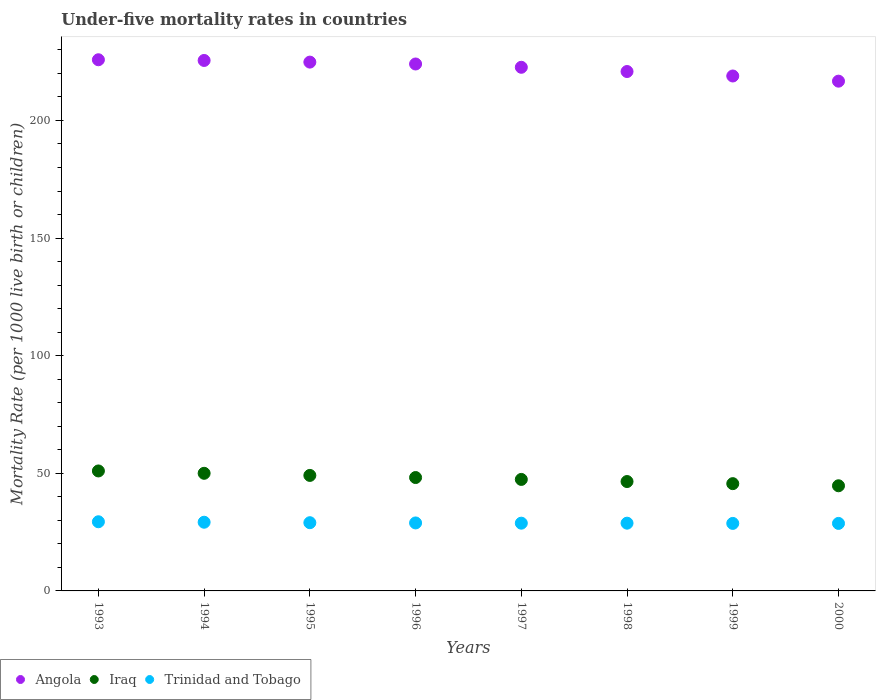Is the number of dotlines equal to the number of legend labels?
Offer a terse response. Yes. What is the under-five mortality rate in Angola in 1997?
Offer a terse response. 222.6. Across all years, what is the maximum under-five mortality rate in Trinidad and Tobago?
Your response must be concise. 29.4. Across all years, what is the minimum under-five mortality rate in Trinidad and Tobago?
Your answer should be very brief. 28.7. In which year was the under-five mortality rate in Iraq minimum?
Give a very brief answer. 2000. What is the total under-five mortality rate in Trinidad and Tobago in the graph?
Offer a very short reply. 231.5. What is the difference between the under-five mortality rate in Iraq in 1993 and that in 2000?
Provide a short and direct response. 6.3. What is the difference between the under-five mortality rate in Trinidad and Tobago in 1999 and the under-five mortality rate in Iraq in 1996?
Offer a terse response. -19.5. What is the average under-five mortality rate in Iraq per year?
Offer a very short reply. 47.81. In the year 2000, what is the difference between the under-five mortality rate in Iraq and under-five mortality rate in Angola?
Your response must be concise. -172. What is the ratio of the under-five mortality rate in Iraq in 1994 to that in 1995?
Your response must be concise. 1.02. Is the under-five mortality rate in Angola in 1993 less than that in 1999?
Ensure brevity in your answer.  No. Is the difference between the under-five mortality rate in Iraq in 1994 and 1997 greater than the difference between the under-five mortality rate in Angola in 1994 and 1997?
Make the answer very short. No. What is the difference between the highest and the lowest under-five mortality rate in Iraq?
Provide a short and direct response. 6.3. In how many years, is the under-five mortality rate in Iraq greater than the average under-five mortality rate in Iraq taken over all years?
Ensure brevity in your answer.  4. Is the sum of the under-five mortality rate in Angola in 1993 and 1994 greater than the maximum under-five mortality rate in Trinidad and Tobago across all years?
Ensure brevity in your answer.  Yes. Is it the case that in every year, the sum of the under-five mortality rate in Angola and under-five mortality rate in Trinidad and Tobago  is greater than the under-five mortality rate in Iraq?
Provide a succinct answer. Yes. Is the under-five mortality rate in Trinidad and Tobago strictly less than the under-five mortality rate in Iraq over the years?
Give a very brief answer. Yes. How many dotlines are there?
Give a very brief answer. 3. Does the graph contain any zero values?
Offer a very short reply. No. How are the legend labels stacked?
Provide a short and direct response. Horizontal. What is the title of the graph?
Offer a very short reply. Under-five mortality rates in countries. Does "Denmark" appear as one of the legend labels in the graph?
Keep it short and to the point. No. What is the label or title of the Y-axis?
Provide a succinct answer. Mortality Rate (per 1000 live birth or children). What is the Mortality Rate (per 1000 live birth or children) in Angola in 1993?
Provide a short and direct response. 225.8. What is the Mortality Rate (per 1000 live birth or children) of Iraq in 1993?
Provide a succinct answer. 51. What is the Mortality Rate (per 1000 live birth or children) in Trinidad and Tobago in 1993?
Provide a short and direct response. 29.4. What is the Mortality Rate (per 1000 live birth or children) of Angola in 1994?
Your answer should be very brief. 225.5. What is the Mortality Rate (per 1000 live birth or children) of Trinidad and Tobago in 1994?
Provide a short and direct response. 29.2. What is the Mortality Rate (per 1000 live birth or children) in Angola in 1995?
Offer a very short reply. 224.8. What is the Mortality Rate (per 1000 live birth or children) in Iraq in 1995?
Your response must be concise. 49.1. What is the Mortality Rate (per 1000 live birth or children) in Angola in 1996?
Make the answer very short. 224. What is the Mortality Rate (per 1000 live birth or children) in Iraq in 1996?
Offer a terse response. 48.2. What is the Mortality Rate (per 1000 live birth or children) in Trinidad and Tobago in 1996?
Your response must be concise. 28.9. What is the Mortality Rate (per 1000 live birth or children) of Angola in 1997?
Offer a very short reply. 222.6. What is the Mortality Rate (per 1000 live birth or children) in Iraq in 1997?
Give a very brief answer. 47.4. What is the Mortality Rate (per 1000 live birth or children) in Trinidad and Tobago in 1997?
Make the answer very short. 28.8. What is the Mortality Rate (per 1000 live birth or children) of Angola in 1998?
Keep it short and to the point. 220.8. What is the Mortality Rate (per 1000 live birth or children) of Iraq in 1998?
Give a very brief answer. 46.5. What is the Mortality Rate (per 1000 live birth or children) of Trinidad and Tobago in 1998?
Keep it short and to the point. 28.8. What is the Mortality Rate (per 1000 live birth or children) in Angola in 1999?
Keep it short and to the point. 218.9. What is the Mortality Rate (per 1000 live birth or children) of Iraq in 1999?
Provide a short and direct response. 45.6. What is the Mortality Rate (per 1000 live birth or children) of Trinidad and Tobago in 1999?
Give a very brief answer. 28.7. What is the Mortality Rate (per 1000 live birth or children) of Angola in 2000?
Give a very brief answer. 216.7. What is the Mortality Rate (per 1000 live birth or children) of Iraq in 2000?
Your answer should be very brief. 44.7. What is the Mortality Rate (per 1000 live birth or children) of Trinidad and Tobago in 2000?
Make the answer very short. 28.7. Across all years, what is the maximum Mortality Rate (per 1000 live birth or children) in Angola?
Give a very brief answer. 225.8. Across all years, what is the maximum Mortality Rate (per 1000 live birth or children) in Trinidad and Tobago?
Offer a terse response. 29.4. Across all years, what is the minimum Mortality Rate (per 1000 live birth or children) of Angola?
Ensure brevity in your answer.  216.7. Across all years, what is the minimum Mortality Rate (per 1000 live birth or children) in Iraq?
Make the answer very short. 44.7. Across all years, what is the minimum Mortality Rate (per 1000 live birth or children) of Trinidad and Tobago?
Your response must be concise. 28.7. What is the total Mortality Rate (per 1000 live birth or children) of Angola in the graph?
Ensure brevity in your answer.  1779.1. What is the total Mortality Rate (per 1000 live birth or children) in Iraq in the graph?
Offer a very short reply. 382.5. What is the total Mortality Rate (per 1000 live birth or children) of Trinidad and Tobago in the graph?
Your answer should be compact. 231.5. What is the difference between the Mortality Rate (per 1000 live birth or children) of Iraq in 1993 and that in 1994?
Give a very brief answer. 1. What is the difference between the Mortality Rate (per 1000 live birth or children) of Trinidad and Tobago in 1993 and that in 1994?
Your answer should be very brief. 0.2. What is the difference between the Mortality Rate (per 1000 live birth or children) of Iraq in 1993 and that in 1995?
Provide a short and direct response. 1.9. What is the difference between the Mortality Rate (per 1000 live birth or children) in Trinidad and Tobago in 1993 and that in 1995?
Provide a short and direct response. 0.4. What is the difference between the Mortality Rate (per 1000 live birth or children) of Angola in 1993 and that in 1996?
Your response must be concise. 1.8. What is the difference between the Mortality Rate (per 1000 live birth or children) in Trinidad and Tobago in 1993 and that in 1996?
Your response must be concise. 0.5. What is the difference between the Mortality Rate (per 1000 live birth or children) in Angola in 1993 and that in 1997?
Make the answer very short. 3.2. What is the difference between the Mortality Rate (per 1000 live birth or children) in Trinidad and Tobago in 1993 and that in 1997?
Offer a very short reply. 0.6. What is the difference between the Mortality Rate (per 1000 live birth or children) of Trinidad and Tobago in 1993 and that in 1998?
Offer a terse response. 0.6. What is the difference between the Mortality Rate (per 1000 live birth or children) in Angola in 1993 and that in 1999?
Your response must be concise. 6.9. What is the difference between the Mortality Rate (per 1000 live birth or children) in Iraq in 1993 and that in 1999?
Offer a very short reply. 5.4. What is the difference between the Mortality Rate (per 1000 live birth or children) in Trinidad and Tobago in 1993 and that in 1999?
Provide a succinct answer. 0.7. What is the difference between the Mortality Rate (per 1000 live birth or children) in Angola in 1993 and that in 2000?
Provide a short and direct response. 9.1. What is the difference between the Mortality Rate (per 1000 live birth or children) in Iraq in 1993 and that in 2000?
Your answer should be very brief. 6.3. What is the difference between the Mortality Rate (per 1000 live birth or children) in Trinidad and Tobago in 1993 and that in 2000?
Make the answer very short. 0.7. What is the difference between the Mortality Rate (per 1000 live birth or children) of Angola in 1994 and that in 1995?
Offer a very short reply. 0.7. What is the difference between the Mortality Rate (per 1000 live birth or children) of Trinidad and Tobago in 1994 and that in 1996?
Ensure brevity in your answer.  0.3. What is the difference between the Mortality Rate (per 1000 live birth or children) in Iraq in 1994 and that in 1998?
Offer a terse response. 3.5. What is the difference between the Mortality Rate (per 1000 live birth or children) in Trinidad and Tobago in 1994 and that in 1998?
Make the answer very short. 0.4. What is the difference between the Mortality Rate (per 1000 live birth or children) of Iraq in 1994 and that in 1999?
Provide a succinct answer. 4.4. What is the difference between the Mortality Rate (per 1000 live birth or children) of Angola in 1994 and that in 2000?
Your answer should be compact. 8.8. What is the difference between the Mortality Rate (per 1000 live birth or children) in Trinidad and Tobago in 1994 and that in 2000?
Provide a short and direct response. 0.5. What is the difference between the Mortality Rate (per 1000 live birth or children) of Angola in 1995 and that in 1996?
Give a very brief answer. 0.8. What is the difference between the Mortality Rate (per 1000 live birth or children) of Iraq in 1995 and that in 1996?
Make the answer very short. 0.9. What is the difference between the Mortality Rate (per 1000 live birth or children) in Trinidad and Tobago in 1995 and that in 1996?
Give a very brief answer. 0.1. What is the difference between the Mortality Rate (per 1000 live birth or children) of Angola in 1995 and that in 1997?
Your answer should be compact. 2.2. What is the difference between the Mortality Rate (per 1000 live birth or children) in Iraq in 1995 and that in 1997?
Make the answer very short. 1.7. What is the difference between the Mortality Rate (per 1000 live birth or children) of Trinidad and Tobago in 1995 and that in 1997?
Provide a short and direct response. 0.2. What is the difference between the Mortality Rate (per 1000 live birth or children) of Iraq in 1995 and that in 1998?
Provide a short and direct response. 2.6. What is the difference between the Mortality Rate (per 1000 live birth or children) in Angola in 1995 and that in 2000?
Your answer should be compact. 8.1. What is the difference between the Mortality Rate (per 1000 live birth or children) of Angola in 1996 and that in 1997?
Keep it short and to the point. 1.4. What is the difference between the Mortality Rate (per 1000 live birth or children) in Iraq in 1996 and that in 1997?
Give a very brief answer. 0.8. What is the difference between the Mortality Rate (per 1000 live birth or children) in Iraq in 1996 and that in 1998?
Keep it short and to the point. 1.7. What is the difference between the Mortality Rate (per 1000 live birth or children) of Trinidad and Tobago in 1996 and that in 1998?
Your answer should be very brief. 0.1. What is the difference between the Mortality Rate (per 1000 live birth or children) in Iraq in 1996 and that in 1999?
Your response must be concise. 2.6. What is the difference between the Mortality Rate (per 1000 live birth or children) in Trinidad and Tobago in 1996 and that in 1999?
Your answer should be very brief. 0.2. What is the difference between the Mortality Rate (per 1000 live birth or children) of Angola in 1996 and that in 2000?
Provide a short and direct response. 7.3. What is the difference between the Mortality Rate (per 1000 live birth or children) of Trinidad and Tobago in 1996 and that in 2000?
Your answer should be compact. 0.2. What is the difference between the Mortality Rate (per 1000 live birth or children) of Trinidad and Tobago in 1997 and that in 1999?
Keep it short and to the point. 0.1. What is the difference between the Mortality Rate (per 1000 live birth or children) in Trinidad and Tobago in 1997 and that in 2000?
Your answer should be very brief. 0.1. What is the difference between the Mortality Rate (per 1000 live birth or children) of Angola in 1998 and that in 1999?
Offer a very short reply. 1.9. What is the difference between the Mortality Rate (per 1000 live birth or children) of Iraq in 1998 and that in 1999?
Ensure brevity in your answer.  0.9. What is the difference between the Mortality Rate (per 1000 live birth or children) of Trinidad and Tobago in 1998 and that in 1999?
Offer a terse response. 0.1. What is the difference between the Mortality Rate (per 1000 live birth or children) in Trinidad and Tobago in 1998 and that in 2000?
Offer a very short reply. 0.1. What is the difference between the Mortality Rate (per 1000 live birth or children) in Angola in 1993 and the Mortality Rate (per 1000 live birth or children) in Iraq in 1994?
Make the answer very short. 175.8. What is the difference between the Mortality Rate (per 1000 live birth or children) of Angola in 1993 and the Mortality Rate (per 1000 live birth or children) of Trinidad and Tobago in 1994?
Provide a succinct answer. 196.6. What is the difference between the Mortality Rate (per 1000 live birth or children) in Iraq in 1993 and the Mortality Rate (per 1000 live birth or children) in Trinidad and Tobago in 1994?
Provide a short and direct response. 21.8. What is the difference between the Mortality Rate (per 1000 live birth or children) in Angola in 1993 and the Mortality Rate (per 1000 live birth or children) in Iraq in 1995?
Give a very brief answer. 176.7. What is the difference between the Mortality Rate (per 1000 live birth or children) in Angola in 1993 and the Mortality Rate (per 1000 live birth or children) in Trinidad and Tobago in 1995?
Make the answer very short. 196.8. What is the difference between the Mortality Rate (per 1000 live birth or children) in Iraq in 1993 and the Mortality Rate (per 1000 live birth or children) in Trinidad and Tobago in 1995?
Make the answer very short. 22. What is the difference between the Mortality Rate (per 1000 live birth or children) in Angola in 1993 and the Mortality Rate (per 1000 live birth or children) in Iraq in 1996?
Give a very brief answer. 177.6. What is the difference between the Mortality Rate (per 1000 live birth or children) in Angola in 1993 and the Mortality Rate (per 1000 live birth or children) in Trinidad and Tobago in 1996?
Provide a succinct answer. 196.9. What is the difference between the Mortality Rate (per 1000 live birth or children) in Iraq in 1993 and the Mortality Rate (per 1000 live birth or children) in Trinidad and Tobago in 1996?
Offer a terse response. 22.1. What is the difference between the Mortality Rate (per 1000 live birth or children) in Angola in 1993 and the Mortality Rate (per 1000 live birth or children) in Iraq in 1997?
Your answer should be very brief. 178.4. What is the difference between the Mortality Rate (per 1000 live birth or children) of Angola in 1993 and the Mortality Rate (per 1000 live birth or children) of Trinidad and Tobago in 1997?
Your response must be concise. 197. What is the difference between the Mortality Rate (per 1000 live birth or children) of Angola in 1993 and the Mortality Rate (per 1000 live birth or children) of Iraq in 1998?
Your answer should be very brief. 179.3. What is the difference between the Mortality Rate (per 1000 live birth or children) in Angola in 1993 and the Mortality Rate (per 1000 live birth or children) in Trinidad and Tobago in 1998?
Ensure brevity in your answer.  197. What is the difference between the Mortality Rate (per 1000 live birth or children) in Angola in 1993 and the Mortality Rate (per 1000 live birth or children) in Iraq in 1999?
Your answer should be compact. 180.2. What is the difference between the Mortality Rate (per 1000 live birth or children) in Angola in 1993 and the Mortality Rate (per 1000 live birth or children) in Trinidad and Tobago in 1999?
Make the answer very short. 197.1. What is the difference between the Mortality Rate (per 1000 live birth or children) of Iraq in 1993 and the Mortality Rate (per 1000 live birth or children) of Trinidad and Tobago in 1999?
Offer a very short reply. 22.3. What is the difference between the Mortality Rate (per 1000 live birth or children) of Angola in 1993 and the Mortality Rate (per 1000 live birth or children) of Iraq in 2000?
Provide a short and direct response. 181.1. What is the difference between the Mortality Rate (per 1000 live birth or children) in Angola in 1993 and the Mortality Rate (per 1000 live birth or children) in Trinidad and Tobago in 2000?
Give a very brief answer. 197.1. What is the difference between the Mortality Rate (per 1000 live birth or children) of Iraq in 1993 and the Mortality Rate (per 1000 live birth or children) of Trinidad and Tobago in 2000?
Ensure brevity in your answer.  22.3. What is the difference between the Mortality Rate (per 1000 live birth or children) in Angola in 1994 and the Mortality Rate (per 1000 live birth or children) in Iraq in 1995?
Keep it short and to the point. 176.4. What is the difference between the Mortality Rate (per 1000 live birth or children) in Angola in 1994 and the Mortality Rate (per 1000 live birth or children) in Trinidad and Tobago in 1995?
Your answer should be very brief. 196.5. What is the difference between the Mortality Rate (per 1000 live birth or children) of Iraq in 1994 and the Mortality Rate (per 1000 live birth or children) of Trinidad and Tobago in 1995?
Provide a succinct answer. 21. What is the difference between the Mortality Rate (per 1000 live birth or children) in Angola in 1994 and the Mortality Rate (per 1000 live birth or children) in Iraq in 1996?
Ensure brevity in your answer.  177.3. What is the difference between the Mortality Rate (per 1000 live birth or children) of Angola in 1994 and the Mortality Rate (per 1000 live birth or children) of Trinidad and Tobago in 1996?
Provide a succinct answer. 196.6. What is the difference between the Mortality Rate (per 1000 live birth or children) of Iraq in 1994 and the Mortality Rate (per 1000 live birth or children) of Trinidad and Tobago in 1996?
Make the answer very short. 21.1. What is the difference between the Mortality Rate (per 1000 live birth or children) of Angola in 1994 and the Mortality Rate (per 1000 live birth or children) of Iraq in 1997?
Your answer should be compact. 178.1. What is the difference between the Mortality Rate (per 1000 live birth or children) in Angola in 1994 and the Mortality Rate (per 1000 live birth or children) in Trinidad and Tobago in 1997?
Offer a very short reply. 196.7. What is the difference between the Mortality Rate (per 1000 live birth or children) of Iraq in 1994 and the Mortality Rate (per 1000 live birth or children) of Trinidad and Tobago in 1997?
Provide a succinct answer. 21.2. What is the difference between the Mortality Rate (per 1000 live birth or children) of Angola in 1994 and the Mortality Rate (per 1000 live birth or children) of Iraq in 1998?
Give a very brief answer. 179. What is the difference between the Mortality Rate (per 1000 live birth or children) of Angola in 1994 and the Mortality Rate (per 1000 live birth or children) of Trinidad and Tobago in 1998?
Your answer should be compact. 196.7. What is the difference between the Mortality Rate (per 1000 live birth or children) in Iraq in 1994 and the Mortality Rate (per 1000 live birth or children) in Trinidad and Tobago in 1998?
Offer a very short reply. 21.2. What is the difference between the Mortality Rate (per 1000 live birth or children) in Angola in 1994 and the Mortality Rate (per 1000 live birth or children) in Iraq in 1999?
Your response must be concise. 179.9. What is the difference between the Mortality Rate (per 1000 live birth or children) in Angola in 1994 and the Mortality Rate (per 1000 live birth or children) in Trinidad and Tobago in 1999?
Keep it short and to the point. 196.8. What is the difference between the Mortality Rate (per 1000 live birth or children) of Iraq in 1994 and the Mortality Rate (per 1000 live birth or children) of Trinidad and Tobago in 1999?
Offer a very short reply. 21.3. What is the difference between the Mortality Rate (per 1000 live birth or children) in Angola in 1994 and the Mortality Rate (per 1000 live birth or children) in Iraq in 2000?
Provide a succinct answer. 180.8. What is the difference between the Mortality Rate (per 1000 live birth or children) in Angola in 1994 and the Mortality Rate (per 1000 live birth or children) in Trinidad and Tobago in 2000?
Your answer should be very brief. 196.8. What is the difference between the Mortality Rate (per 1000 live birth or children) of Iraq in 1994 and the Mortality Rate (per 1000 live birth or children) of Trinidad and Tobago in 2000?
Ensure brevity in your answer.  21.3. What is the difference between the Mortality Rate (per 1000 live birth or children) of Angola in 1995 and the Mortality Rate (per 1000 live birth or children) of Iraq in 1996?
Your response must be concise. 176.6. What is the difference between the Mortality Rate (per 1000 live birth or children) of Angola in 1995 and the Mortality Rate (per 1000 live birth or children) of Trinidad and Tobago in 1996?
Keep it short and to the point. 195.9. What is the difference between the Mortality Rate (per 1000 live birth or children) in Iraq in 1995 and the Mortality Rate (per 1000 live birth or children) in Trinidad and Tobago in 1996?
Your response must be concise. 20.2. What is the difference between the Mortality Rate (per 1000 live birth or children) in Angola in 1995 and the Mortality Rate (per 1000 live birth or children) in Iraq in 1997?
Your response must be concise. 177.4. What is the difference between the Mortality Rate (per 1000 live birth or children) of Angola in 1995 and the Mortality Rate (per 1000 live birth or children) of Trinidad and Tobago in 1997?
Your answer should be very brief. 196. What is the difference between the Mortality Rate (per 1000 live birth or children) of Iraq in 1995 and the Mortality Rate (per 1000 live birth or children) of Trinidad and Tobago in 1997?
Your answer should be very brief. 20.3. What is the difference between the Mortality Rate (per 1000 live birth or children) of Angola in 1995 and the Mortality Rate (per 1000 live birth or children) of Iraq in 1998?
Give a very brief answer. 178.3. What is the difference between the Mortality Rate (per 1000 live birth or children) of Angola in 1995 and the Mortality Rate (per 1000 live birth or children) of Trinidad and Tobago in 1998?
Offer a terse response. 196. What is the difference between the Mortality Rate (per 1000 live birth or children) in Iraq in 1995 and the Mortality Rate (per 1000 live birth or children) in Trinidad and Tobago in 1998?
Provide a succinct answer. 20.3. What is the difference between the Mortality Rate (per 1000 live birth or children) in Angola in 1995 and the Mortality Rate (per 1000 live birth or children) in Iraq in 1999?
Give a very brief answer. 179.2. What is the difference between the Mortality Rate (per 1000 live birth or children) in Angola in 1995 and the Mortality Rate (per 1000 live birth or children) in Trinidad and Tobago in 1999?
Ensure brevity in your answer.  196.1. What is the difference between the Mortality Rate (per 1000 live birth or children) of Iraq in 1995 and the Mortality Rate (per 1000 live birth or children) of Trinidad and Tobago in 1999?
Offer a very short reply. 20.4. What is the difference between the Mortality Rate (per 1000 live birth or children) in Angola in 1995 and the Mortality Rate (per 1000 live birth or children) in Iraq in 2000?
Your response must be concise. 180.1. What is the difference between the Mortality Rate (per 1000 live birth or children) of Angola in 1995 and the Mortality Rate (per 1000 live birth or children) of Trinidad and Tobago in 2000?
Make the answer very short. 196.1. What is the difference between the Mortality Rate (per 1000 live birth or children) in Iraq in 1995 and the Mortality Rate (per 1000 live birth or children) in Trinidad and Tobago in 2000?
Offer a very short reply. 20.4. What is the difference between the Mortality Rate (per 1000 live birth or children) of Angola in 1996 and the Mortality Rate (per 1000 live birth or children) of Iraq in 1997?
Make the answer very short. 176.6. What is the difference between the Mortality Rate (per 1000 live birth or children) of Angola in 1996 and the Mortality Rate (per 1000 live birth or children) of Trinidad and Tobago in 1997?
Provide a short and direct response. 195.2. What is the difference between the Mortality Rate (per 1000 live birth or children) of Angola in 1996 and the Mortality Rate (per 1000 live birth or children) of Iraq in 1998?
Offer a very short reply. 177.5. What is the difference between the Mortality Rate (per 1000 live birth or children) of Angola in 1996 and the Mortality Rate (per 1000 live birth or children) of Trinidad and Tobago in 1998?
Provide a short and direct response. 195.2. What is the difference between the Mortality Rate (per 1000 live birth or children) of Angola in 1996 and the Mortality Rate (per 1000 live birth or children) of Iraq in 1999?
Your response must be concise. 178.4. What is the difference between the Mortality Rate (per 1000 live birth or children) in Angola in 1996 and the Mortality Rate (per 1000 live birth or children) in Trinidad and Tobago in 1999?
Make the answer very short. 195.3. What is the difference between the Mortality Rate (per 1000 live birth or children) in Angola in 1996 and the Mortality Rate (per 1000 live birth or children) in Iraq in 2000?
Provide a succinct answer. 179.3. What is the difference between the Mortality Rate (per 1000 live birth or children) of Angola in 1996 and the Mortality Rate (per 1000 live birth or children) of Trinidad and Tobago in 2000?
Offer a terse response. 195.3. What is the difference between the Mortality Rate (per 1000 live birth or children) of Iraq in 1996 and the Mortality Rate (per 1000 live birth or children) of Trinidad and Tobago in 2000?
Offer a terse response. 19.5. What is the difference between the Mortality Rate (per 1000 live birth or children) of Angola in 1997 and the Mortality Rate (per 1000 live birth or children) of Iraq in 1998?
Offer a terse response. 176.1. What is the difference between the Mortality Rate (per 1000 live birth or children) in Angola in 1997 and the Mortality Rate (per 1000 live birth or children) in Trinidad and Tobago in 1998?
Give a very brief answer. 193.8. What is the difference between the Mortality Rate (per 1000 live birth or children) in Angola in 1997 and the Mortality Rate (per 1000 live birth or children) in Iraq in 1999?
Keep it short and to the point. 177. What is the difference between the Mortality Rate (per 1000 live birth or children) in Angola in 1997 and the Mortality Rate (per 1000 live birth or children) in Trinidad and Tobago in 1999?
Provide a succinct answer. 193.9. What is the difference between the Mortality Rate (per 1000 live birth or children) of Angola in 1997 and the Mortality Rate (per 1000 live birth or children) of Iraq in 2000?
Your answer should be very brief. 177.9. What is the difference between the Mortality Rate (per 1000 live birth or children) in Angola in 1997 and the Mortality Rate (per 1000 live birth or children) in Trinidad and Tobago in 2000?
Provide a short and direct response. 193.9. What is the difference between the Mortality Rate (per 1000 live birth or children) of Iraq in 1997 and the Mortality Rate (per 1000 live birth or children) of Trinidad and Tobago in 2000?
Your response must be concise. 18.7. What is the difference between the Mortality Rate (per 1000 live birth or children) of Angola in 1998 and the Mortality Rate (per 1000 live birth or children) of Iraq in 1999?
Your answer should be compact. 175.2. What is the difference between the Mortality Rate (per 1000 live birth or children) in Angola in 1998 and the Mortality Rate (per 1000 live birth or children) in Trinidad and Tobago in 1999?
Give a very brief answer. 192.1. What is the difference between the Mortality Rate (per 1000 live birth or children) of Iraq in 1998 and the Mortality Rate (per 1000 live birth or children) of Trinidad and Tobago in 1999?
Offer a terse response. 17.8. What is the difference between the Mortality Rate (per 1000 live birth or children) of Angola in 1998 and the Mortality Rate (per 1000 live birth or children) of Iraq in 2000?
Provide a short and direct response. 176.1. What is the difference between the Mortality Rate (per 1000 live birth or children) of Angola in 1998 and the Mortality Rate (per 1000 live birth or children) of Trinidad and Tobago in 2000?
Offer a very short reply. 192.1. What is the difference between the Mortality Rate (per 1000 live birth or children) of Iraq in 1998 and the Mortality Rate (per 1000 live birth or children) of Trinidad and Tobago in 2000?
Keep it short and to the point. 17.8. What is the difference between the Mortality Rate (per 1000 live birth or children) in Angola in 1999 and the Mortality Rate (per 1000 live birth or children) in Iraq in 2000?
Your answer should be compact. 174.2. What is the difference between the Mortality Rate (per 1000 live birth or children) of Angola in 1999 and the Mortality Rate (per 1000 live birth or children) of Trinidad and Tobago in 2000?
Provide a succinct answer. 190.2. What is the average Mortality Rate (per 1000 live birth or children) of Angola per year?
Keep it short and to the point. 222.39. What is the average Mortality Rate (per 1000 live birth or children) of Iraq per year?
Provide a succinct answer. 47.81. What is the average Mortality Rate (per 1000 live birth or children) of Trinidad and Tobago per year?
Give a very brief answer. 28.94. In the year 1993, what is the difference between the Mortality Rate (per 1000 live birth or children) of Angola and Mortality Rate (per 1000 live birth or children) of Iraq?
Your answer should be very brief. 174.8. In the year 1993, what is the difference between the Mortality Rate (per 1000 live birth or children) in Angola and Mortality Rate (per 1000 live birth or children) in Trinidad and Tobago?
Your answer should be very brief. 196.4. In the year 1993, what is the difference between the Mortality Rate (per 1000 live birth or children) in Iraq and Mortality Rate (per 1000 live birth or children) in Trinidad and Tobago?
Your answer should be very brief. 21.6. In the year 1994, what is the difference between the Mortality Rate (per 1000 live birth or children) of Angola and Mortality Rate (per 1000 live birth or children) of Iraq?
Ensure brevity in your answer.  175.5. In the year 1994, what is the difference between the Mortality Rate (per 1000 live birth or children) in Angola and Mortality Rate (per 1000 live birth or children) in Trinidad and Tobago?
Make the answer very short. 196.3. In the year 1994, what is the difference between the Mortality Rate (per 1000 live birth or children) in Iraq and Mortality Rate (per 1000 live birth or children) in Trinidad and Tobago?
Offer a very short reply. 20.8. In the year 1995, what is the difference between the Mortality Rate (per 1000 live birth or children) in Angola and Mortality Rate (per 1000 live birth or children) in Iraq?
Make the answer very short. 175.7. In the year 1995, what is the difference between the Mortality Rate (per 1000 live birth or children) in Angola and Mortality Rate (per 1000 live birth or children) in Trinidad and Tobago?
Your answer should be compact. 195.8. In the year 1995, what is the difference between the Mortality Rate (per 1000 live birth or children) in Iraq and Mortality Rate (per 1000 live birth or children) in Trinidad and Tobago?
Provide a succinct answer. 20.1. In the year 1996, what is the difference between the Mortality Rate (per 1000 live birth or children) of Angola and Mortality Rate (per 1000 live birth or children) of Iraq?
Provide a short and direct response. 175.8. In the year 1996, what is the difference between the Mortality Rate (per 1000 live birth or children) in Angola and Mortality Rate (per 1000 live birth or children) in Trinidad and Tobago?
Offer a very short reply. 195.1. In the year 1996, what is the difference between the Mortality Rate (per 1000 live birth or children) in Iraq and Mortality Rate (per 1000 live birth or children) in Trinidad and Tobago?
Provide a short and direct response. 19.3. In the year 1997, what is the difference between the Mortality Rate (per 1000 live birth or children) in Angola and Mortality Rate (per 1000 live birth or children) in Iraq?
Provide a succinct answer. 175.2. In the year 1997, what is the difference between the Mortality Rate (per 1000 live birth or children) of Angola and Mortality Rate (per 1000 live birth or children) of Trinidad and Tobago?
Your answer should be very brief. 193.8. In the year 1997, what is the difference between the Mortality Rate (per 1000 live birth or children) in Iraq and Mortality Rate (per 1000 live birth or children) in Trinidad and Tobago?
Keep it short and to the point. 18.6. In the year 1998, what is the difference between the Mortality Rate (per 1000 live birth or children) in Angola and Mortality Rate (per 1000 live birth or children) in Iraq?
Your answer should be very brief. 174.3. In the year 1998, what is the difference between the Mortality Rate (per 1000 live birth or children) in Angola and Mortality Rate (per 1000 live birth or children) in Trinidad and Tobago?
Offer a terse response. 192. In the year 1998, what is the difference between the Mortality Rate (per 1000 live birth or children) of Iraq and Mortality Rate (per 1000 live birth or children) of Trinidad and Tobago?
Your answer should be very brief. 17.7. In the year 1999, what is the difference between the Mortality Rate (per 1000 live birth or children) of Angola and Mortality Rate (per 1000 live birth or children) of Iraq?
Provide a succinct answer. 173.3. In the year 1999, what is the difference between the Mortality Rate (per 1000 live birth or children) in Angola and Mortality Rate (per 1000 live birth or children) in Trinidad and Tobago?
Offer a very short reply. 190.2. In the year 1999, what is the difference between the Mortality Rate (per 1000 live birth or children) of Iraq and Mortality Rate (per 1000 live birth or children) of Trinidad and Tobago?
Offer a very short reply. 16.9. In the year 2000, what is the difference between the Mortality Rate (per 1000 live birth or children) in Angola and Mortality Rate (per 1000 live birth or children) in Iraq?
Your answer should be compact. 172. In the year 2000, what is the difference between the Mortality Rate (per 1000 live birth or children) in Angola and Mortality Rate (per 1000 live birth or children) in Trinidad and Tobago?
Provide a short and direct response. 188. What is the ratio of the Mortality Rate (per 1000 live birth or children) in Angola in 1993 to that in 1994?
Your answer should be compact. 1. What is the ratio of the Mortality Rate (per 1000 live birth or children) of Iraq in 1993 to that in 1994?
Provide a succinct answer. 1.02. What is the ratio of the Mortality Rate (per 1000 live birth or children) of Trinidad and Tobago in 1993 to that in 1994?
Provide a succinct answer. 1.01. What is the ratio of the Mortality Rate (per 1000 live birth or children) in Iraq in 1993 to that in 1995?
Offer a very short reply. 1.04. What is the ratio of the Mortality Rate (per 1000 live birth or children) of Trinidad and Tobago in 1993 to that in 1995?
Your answer should be compact. 1.01. What is the ratio of the Mortality Rate (per 1000 live birth or children) in Iraq in 1993 to that in 1996?
Provide a short and direct response. 1.06. What is the ratio of the Mortality Rate (per 1000 live birth or children) in Trinidad and Tobago in 1993 to that in 1996?
Provide a succinct answer. 1.02. What is the ratio of the Mortality Rate (per 1000 live birth or children) of Angola in 1993 to that in 1997?
Your answer should be compact. 1.01. What is the ratio of the Mortality Rate (per 1000 live birth or children) of Iraq in 1993 to that in 1997?
Give a very brief answer. 1.08. What is the ratio of the Mortality Rate (per 1000 live birth or children) in Trinidad and Tobago in 1993 to that in 1997?
Provide a succinct answer. 1.02. What is the ratio of the Mortality Rate (per 1000 live birth or children) of Angola in 1993 to that in 1998?
Keep it short and to the point. 1.02. What is the ratio of the Mortality Rate (per 1000 live birth or children) in Iraq in 1993 to that in 1998?
Provide a succinct answer. 1.1. What is the ratio of the Mortality Rate (per 1000 live birth or children) in Trinidad and Tobago in 1993 to that in 1998?
Keep it short and to the point. 1.02. What is the ratio of the Mortality Rate (per 1000 live birth or children) in Angola in 1993 to that in 1999?
Make the answer very short. 1.03. What is the ratio of the Mortality Rate (per 1000 live birth or children) of Iraq in 1993 to that in 1999?
Offer a terse response. 1.12. What is the ratio of the Mortality Rate (per 1000 live birth or children) in Trinidad and Tobago in 1993 to that in 1999?
Ensure brevity in your answer.  1.02. What is the ratio of the Mortality Rate (per 1000 live birth or children) in Angola in 1993 to that in 2000?
Offer a terse response. 1.04. What is the ratio of the Mortality Rate (per 1000 live birth or children) of Iraq in 1993 to that in 2000?
Your response must be concise. 1.14. What is the ratio of the Mortality Rate (per 1000 live birth or children) in Trinidad and Tobago in 1993 to that in 2000?
Offer a terse response. 1.02. What is the ratio of the Mortality Rate (per 1000 live birth or children) of Angola in 1994 to that in 1995?
Give a very brief answer. 1. What is the ratio of the Mortality Rate (per 1000 live birth or children) in Iraq in 1994 to that in 1995?
Provide a succinct answer. 1.02. What is the ratio of the Mortality Rate (per 1000 live birth or children) in Trinidad and Tobago in 1994 to that in 1995?
Your answer should be compact. 1.01. What is the ratio of the Mortality Rate (per 1000 live birth or children) of Iraq in 1994 to that in 1996?
Your response must be concise. 1.04. What is the ratio of the Mortality Rate (per 1000 live birth or children) in Trinidad and Tobago in 1994 to that in 1996?
Give a very brief answer. 1.01. What is the ratio of the Mortality Rate (per 1000 live birth or children) in Angola in 1994 to that in 1997?
Offer a very short reply. 1.01. What is the ratio of the Mortality Rate (per 1000 live birth or children) in Iraq in 1994 to that in 1997?
Ensure brevity in your answer.  1.05. What is the ratio of the Mortality Rate (per 1000 live birth or children) in Trinidad and Tobago in 1994 to that in 1997?
Your answer should be very brief. 1.01. What is the ratio of the Mortality Rate (per 1000 live birth or children) of Angola in 1994 to that in 1998?
Provide a short and direct response. 1.02. What is the ratio of the Mortality Rate (per 1000 live birth or children) of Iraq in 1994 to that in 1998?
Make the answer very short. 1.08. What is the ratio of the Mortality Rate (per 1000 live birth or children) of Trinidad and Tobago in 1994 to that in 1998?
Make the answer very short. 1.01. What is the ratio of the Mortality Rate (per 1000 live birth or children) in Angola in 1994 to that in 1999?
Offer a terse response. 1.03. What is the ratio of the Mortality Rate (per 1000 live birth or children) of Iraq in 1994 to that in 1999?
Your answer should be very brief. 1.1. What is the ratio of the Mortality Rate (per 1000 live birth or children) in Trinidad and Tobago in 1994 to that in 1999?
Offer a very short reply. 1.02. What is the ratio of the Mortality Rate (per 1000 live birth or children) of Angola in 1994 to that in 2000?
Ensure brevity in your answer.  1.04. What is the ratio of the Mortality Rate (per 1000 live birth or children) of Iraq in 1994 to that in 2000?
Give a very brief answer. 1.12. What is the ratio of the Mortality Rate (per 1000 live birth or children) of Trinidad and Tobago in 1994 to that in 2000?
Ensure brevity in your answer.  1.02. What is the ratio of the Mortality Rate (per 1000 live birth or children) of Iraq in 1995 to that in 1996?
Ensure brevity in your answer.  1.02. What is the ratio of the Mortality Rate (per 1000 live birth or children) in Angola in 1995 to that in 1997?
Give a very brief answer. 1.01. What is the ratio of the Mortality Rate (per 1000 live birth or children) of Iraq in 1995 to that in 1997?
Keep it short and to the point. 1.04. What is the ratio of the Mortality Rate (per 1000 live birth or children) in Angola in 1995 to that in 1998?
Your answer should be very brief. 1.02. What is the ratio of the Mortality Rate (per 1000 live birth or children) in Iraq in 1995 to that in 1998?
Your response must be concise. 1.06. What is the ratio of the Mortality Rate (per 1000 live birth or children) in Trinidad and Tobago in 1995 to that in 1998?
Make the answer very short. 1.01. What is the ratio of the Mortality Rate (per 1000 live birth or children) of Angola in 1995 to that in 1999?
Offer a terse response. 1.03. What is the ratio of the Mortality Rate (per 1000 live birth or children) in Iraq in 1995 to that in 1999?
Give a very brief answer. 1.08. What is the ratio of the Mortality Rate (per 1000 live birth or children) of Trinidad and Tobago in 1995 to that in 1999?
Ensure brevity in your answer.  1.01. What is the ratio of the Mortality Rate (per 1000 live birth or children) in Angola in 1995 to that in 2000?
Your answer should be very brief. 1.04. What is the ratio of the Mortality Rate (per 1000 live birth or children) of Iraq in 1995 to that in 2000?
Provide a succinct answer. 1.1. What is the ratio of the Mortality Rate (per 1000 live birth or children) in Trinidad and Tobago in 1995 to that in 2000?
Offer a very short reply. 1.01. What is the ratio of the Mortality Rate (per 1000 live birth or children) of Angola in 1996 to that in 1997?
Your answer should be compact. 1.01. What is the ratio of the Mortality Rate (per 1000 live birth or children) in Iraq in 1996 to that in 1997?
Provide a short and direct response. 1.02. What is the ratio of the Mortality Rate (per 1000 live birth or children) in Trinidad and Tobago in 1996 to that in 1997?
Offer a very short reply. 1. What is the ratio of the Mortality Rate (per 1000 live birth or children) of Angola in 1996 to that in 1998?
Your answer should be compact. 1.01. What is the ratio of the Mortality Rate (per 1000 live birth or children) in Iraq in 1996 to that in 1998?
Your answer should be compact. 1.04. What is the ratio of the Mortality Rate (per 1000 live birth or children) in Trinidad and Tobago in 1996 to that in 1998?
Provide a succinct answer. 1. What is the ratio of the Mortality Rate (per 1000 live birth or children) in Angola in 1996 to that in 1999?
Provide a succinct answer. 1.02. What is the ratio of the Mortality Rate (per 1000 live birth or children) of Iraq in 1996 to that in 1999?
Offer a terse response. 1.06. What is the ratio of the Mortality Rate (per 1000 live birth or children) in Trinidad and Tobago in 1996 to that in 1999?
Ensure brevity in your answer.  1.01. What is the ratio of the Mortality Rate (per 1000 live birth or children) of Angola in 1996 to that in 2000?
Provide a succinct answer. 1.03. What is the ratio of the Mortality Rate (per 1000 live birth or children) of Iraq in 1996 to that in 2000?
Your answer should be very brief. 1.08. What is the ratio of the Mortality Rate (per 1000 live birth or children) of Trinidad and Tobago in 1996 to that in 2000?
Provide a short and direct response. 1.01. What is the ratio of the Mortality Rate (per 1000 live birth or children) in Angola in 1997 to that in 1998?
Offer a terse response. 1.01. What is the ratio of the Mortality Rate (per 1000 live birth or children) in Iraq in 1997 to that in 1998?
Your answer should be compact. 1.02. What is the ratio of the Mortality Rate (per 1000 live birth or children) of Angola in 1997 to that in 1999?
Your answer should be compact. 1.02. What is the ratio of the Mortality Rate (per 1000 live birth or children) in Iraq in 1997 to that in 1999?
Keep it short and to the point. 1.04. What is the ratio of the Mortality Rate (per 1000 live birth or children) of Trinidad and Tobago in 1997 to that in 1999?
Provide a short and direct response. 1. What is the ratio of the Mortality Rate (per 1000 live birth or children) in Angola in 1997 to that in 2000?
Your response must be concise. 1.03. What is the ratio of the Mortality Rate (per 1000 live birth or children) in Iraq in 1997 to that in 2000?
Your answer should be very brief. 1.06. What is the ratio of the Mortality Rate (per 1000 live birth or children) of Angola in 1998 to that in 1999?
Give a very brief answer. 1.01. What is the ratio of the Mortality Rate (per 1000 live birth or children) of Iraq in 1998 to that in 1999?
Make the answer very short. 1.02. What is the ratio of the Mortality Rate (per 1000 live birth or children) of Angola in 1998 to that in 2000?
Your answer should be very brief. 1.02. What is the ratio of the Mortality Rate (per 1000 live birth or children) of Iraq in 1998 to that in 2000?
Give a very brief answer. 1.04. What is the ratio of the Mortality Rate (per 1000 live birth or children) in Angola in 1999 to that in 2000?
Provide a succinct answer. 1.01. What is the ratio of the Mortality Rate (per 1000 live birth or children) in Iraq in 1999 to that in 2000?
Offer a very short reply. 1.02. What is the ratio of the Mortality Rate (per 1000 live birth or children) in Trinidad and Tobago in 1999 to that in 2000?
Provide a succinct answer. 1. What is the difference between the highest and the second highest Mortality Rate (per 1000 live birth or children) of Angola?
Ensure brevity in your answer.  0.3. What is the difference between the highest and the second highest Mortality Rate (per 1000 live birth or children) of Iraq?
Offer a terse response. 1. What is the difference between the highest and the lowest Mortality Rate (per 1000 live birth or children) in Iraq?
Keep it short and to the point. 6.3. 